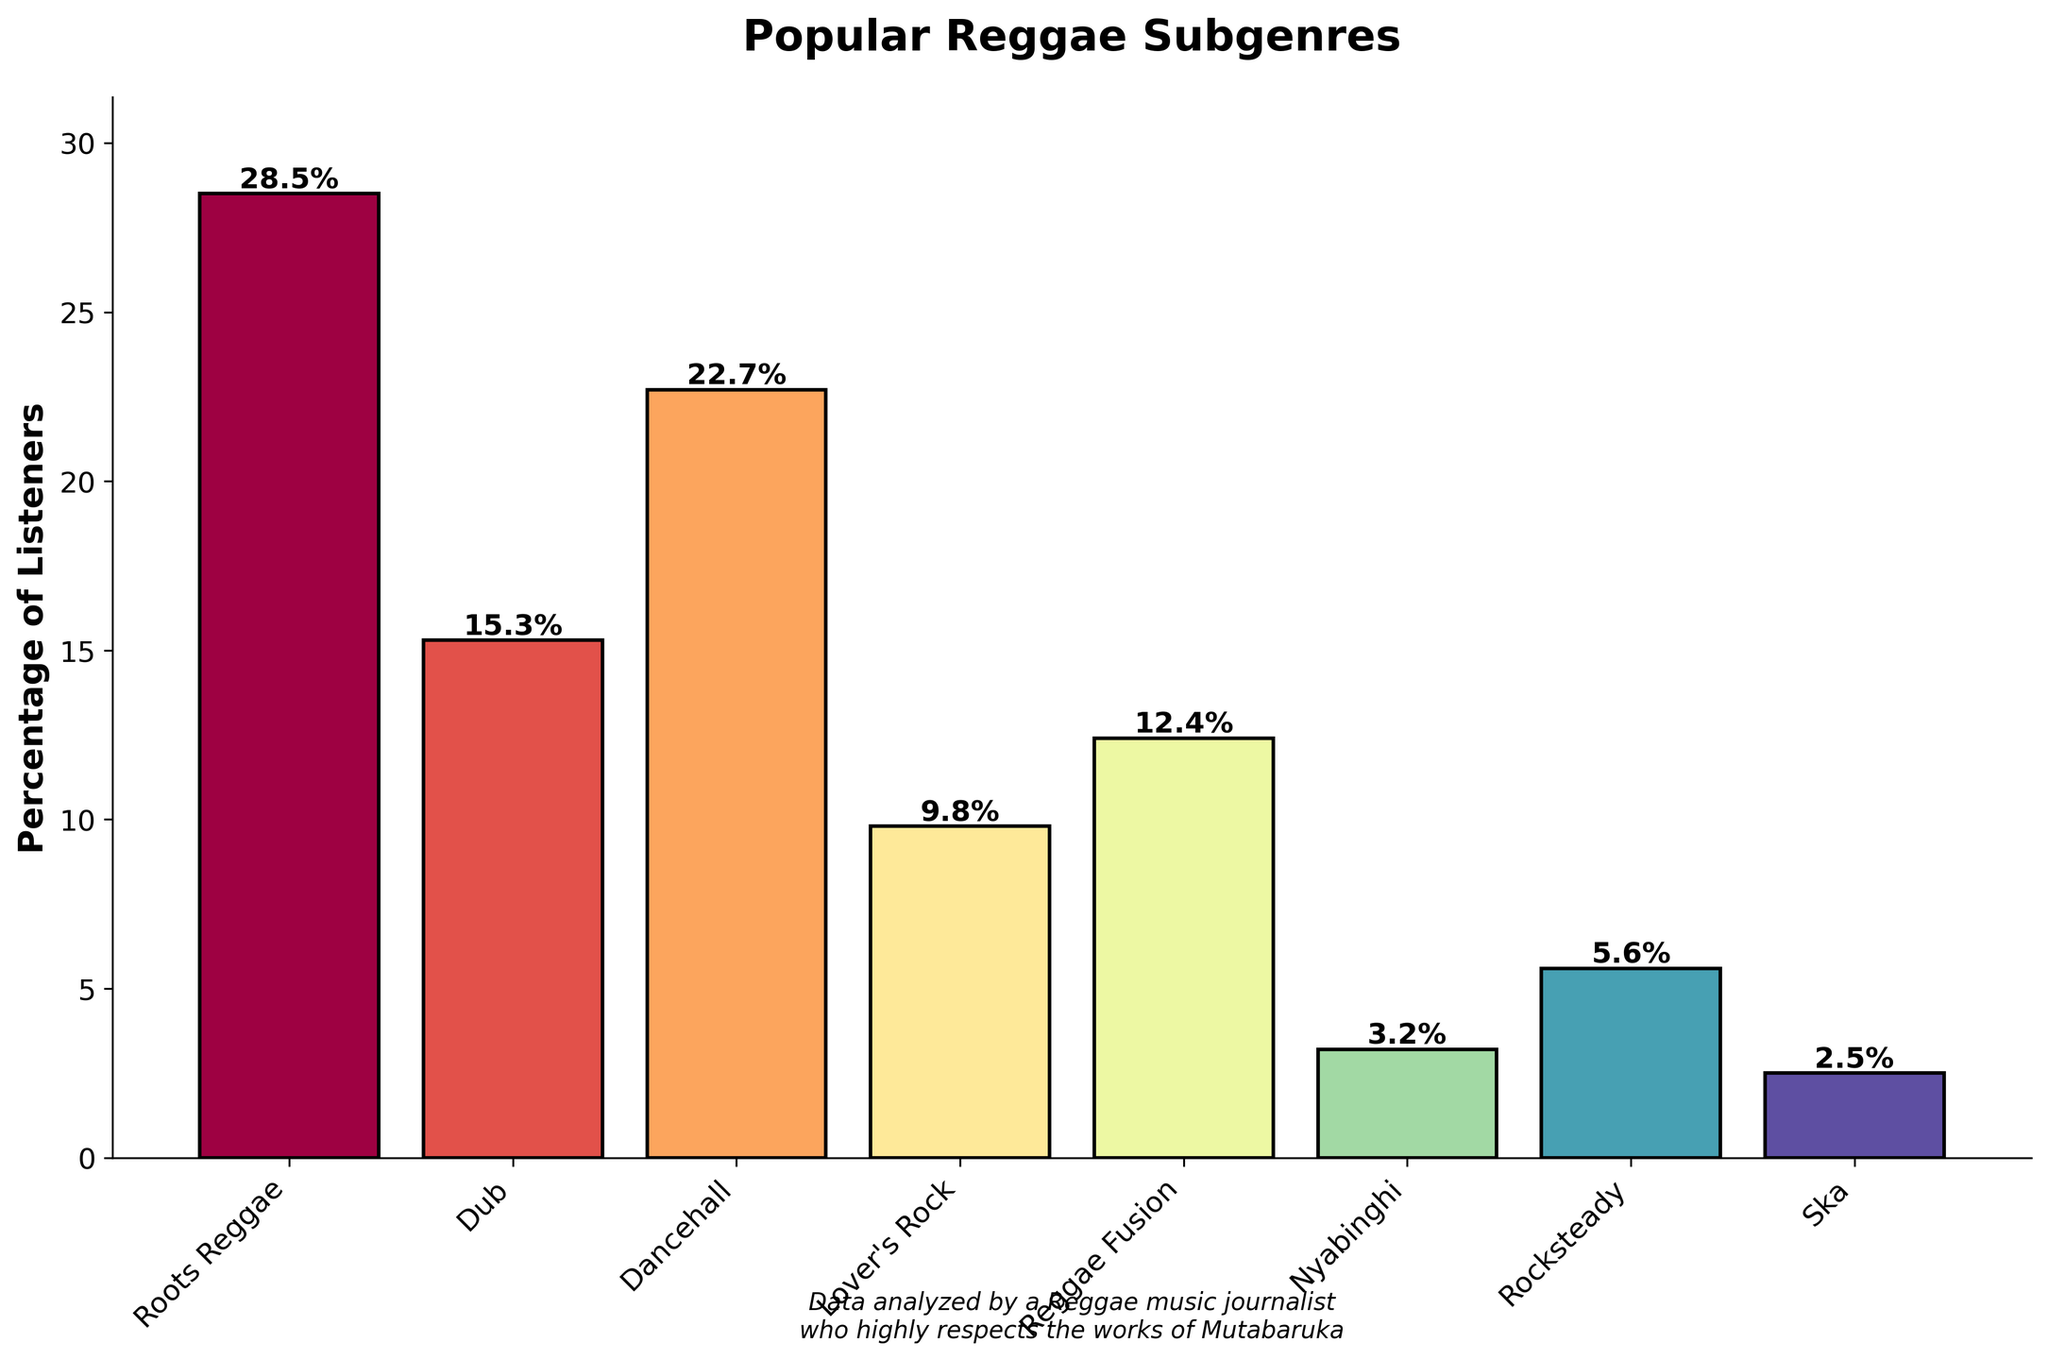What is the percentage of listeners for Roots Reggae? The bar for Roots Reggae indicates its height, which corresponds to the percentage of listeners. The text above the bar shows "28.5%".
Answer: 28.5% Which subgenre has the lowest percentage of listeners? By visually comparing the heights of the bars, the shortest bar belongs to Ska. Hence, Ska has the lowest percentage of listeners.
Answer: Ska How much greater is the percentage of listeners for Roots Reggae compared to Reggae Fusion? First, find the percentages for Roots Reggae (28.5%) and Reggae Fusion (12.4%). Subtract Reggae Fusion's percentage from Roots Reggae's percentage: 28.5% - 12.4% = 16.1%.
Answer: 16.1% What is the combined percentage of listeners for Dancehall and Lover's Rock? Add the percentages of Dancehall (22.7%) and Lover's Rock (9.8%) to get the total: 22.7% + 9.8% = 32.5%.
Answer: 32.5% Which subgenre has a percentage of listeners closest to 10%? Looking at the bars, Lover's Rock has a percentage of 9.8%, which is closest to 10%.
Answer: Lover's Rock How many subgenres have a percentage of listeners above 10%? Check each subgenre's percentage: Roots Reggae (28.5%), Dub (15.3%), Dancehall (22.7%), Lover's Rock (9.8%), Reggae Fusion (12.4%), Nyabinghi (3.2%), Rocksteady (5.6%), and Ska (2.5%). Count those above 10%: 4 subgenres (Roots Reggae, Dub, Dancehall, Reggae Fusion).
Answer: 4 Which subgenre has the second highest percentage of listeners? Identify the subgenres in descending order of their percentages: Roots Reggae (28.5%), Dancehall (22.7%), Dub (15.3%), etc. The second highest is Dancehall with 22.7%.
Answer: Dancehall What is the sum of the percentages of listeners for the three subgenres with the lowest percentages? Identify the three subgenres with the lowest percentages: Ska (2.5%), Nyabinghi (3.2%), and Rocksteady (5.6%). Add their percentages: 2.5% + 3.2% + 5.6% = 11.3%.
Answer: 11.3% Which bar is located at the third position from the left, and what is its percentage? The bars from left to right are Roots Reggae, Dub, Dancehall, etc. The third bar from the left is Dancehall. The percentage is shown as 22.7%.
Answer: Dancehall, 22.7% Compare the percentages of listeners for Dub and Ska, and determine the difference. Find the percentages: Dub (15.3%) and Ska (2.5%). Calculate the difference: 15.3% - 2.5% = 12.8%.
Answer: 12.8% 